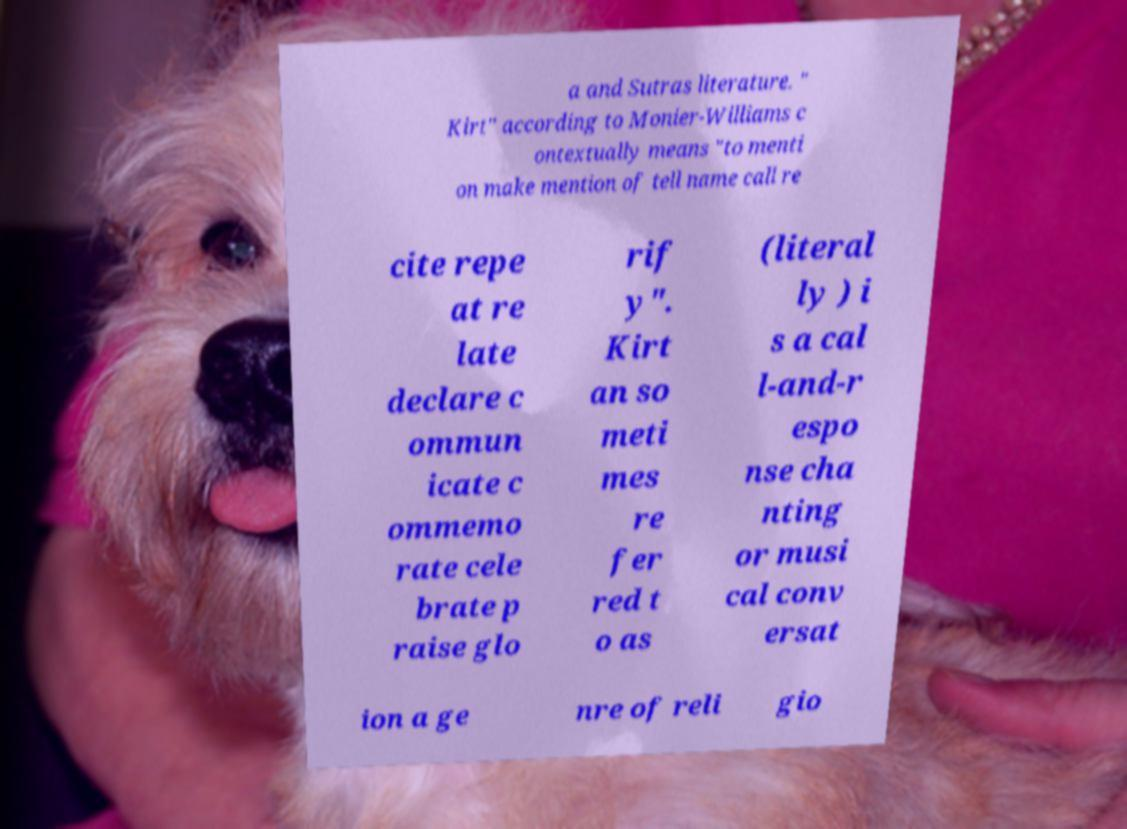There's text embedded in this image that I need extracted. Can you transcribe it verbatim? a and Sutras literature. " Kirt" according to Monier-Williams c ontextually means "to menti on make mention of tell name call re cite repe at re late declare c ommun icate c ommemo rate cele brate p raise glo rif y". Kirt an so meti mes re fer red t o as (literal ly ) i s a cal l-and-r espo nse cha nting or musi cal conv ersat ion a ge nre of reli gio 